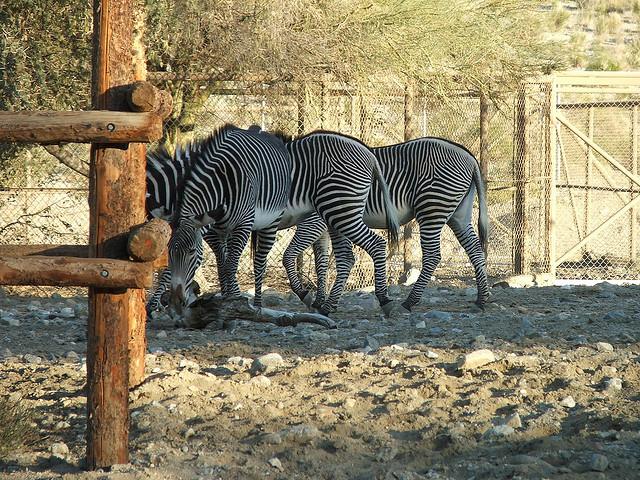What type of enclosure is behind the zebras?
Quick response, please. Fence. What are the zebra doing?
Give a very brief answer. Eating. Are the zebra looking for food?
Give a very brief answer. Yes. 